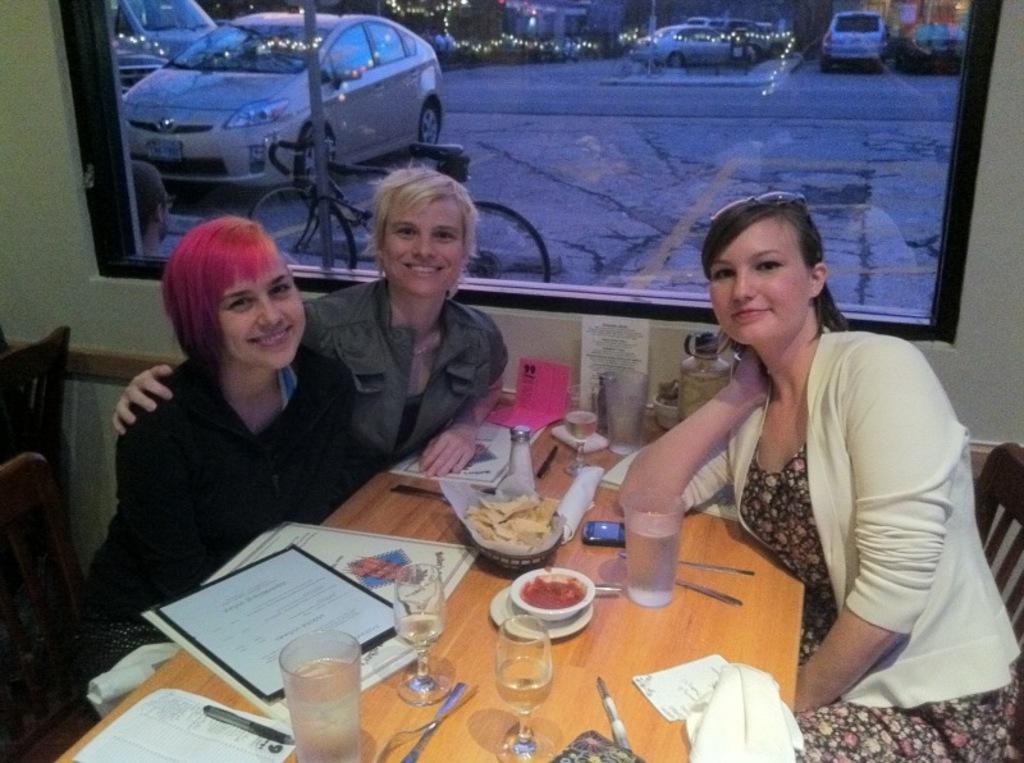Describe this image in one or two sentences. In the center we can see three persons were sitting on the chair around the table,on table we can see food items. And coming to background we can see glass,vehicles,light and road. 